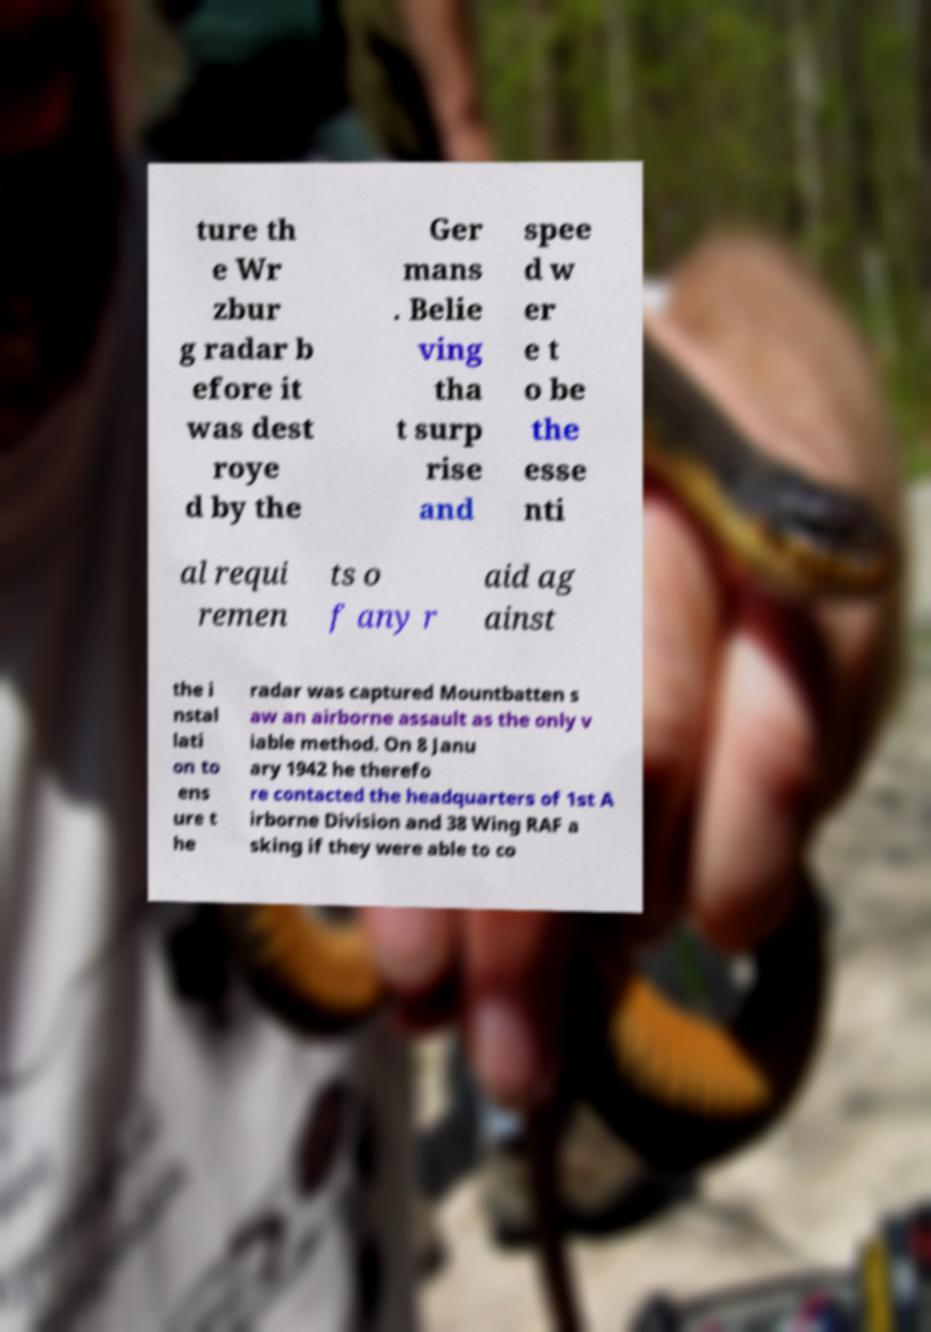There's text embedded in this image that I need extracted. Can you transcribe it verbatim? ture th e Wr zbur g radar b efore it was dest roye d by the Ger mans . Belie ving tha t surp rise and spee d w er e t o be the esse nti al requi remen ts o f any r aid ag ainst the i nstal lati on to ens ure t he radar was captured Mountbatten s aw an airborne assault as the only v iable method. On 8 Janu ary 1942 he therefo re contacted the headquarters of 1st A irborne Division and 38 Wing RAF a sking if they were able to co 